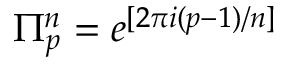Convert formula to latex. <formula><loc_0><loc_0><loc_500><loc_500>\Pi _ { p } ^ { n } = e ^ { [ 2 \pi i ( p - 1 ) / n ] }</formula> 